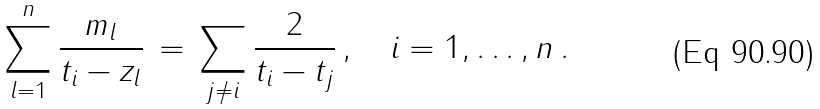Convert formula to latex. <formula><loc_0><loc_0><loc_500><loc_500>\sum _ { l = 1 } ^ { n } \frac { m _ { l } } { t _ { i } - z _ { l } } \, = \, \sum _ { j \neq i } \frac { 2 } { t _ { i } - t _ { j } } \, , \quad i = 1 , \dots , n \, .</formula> 